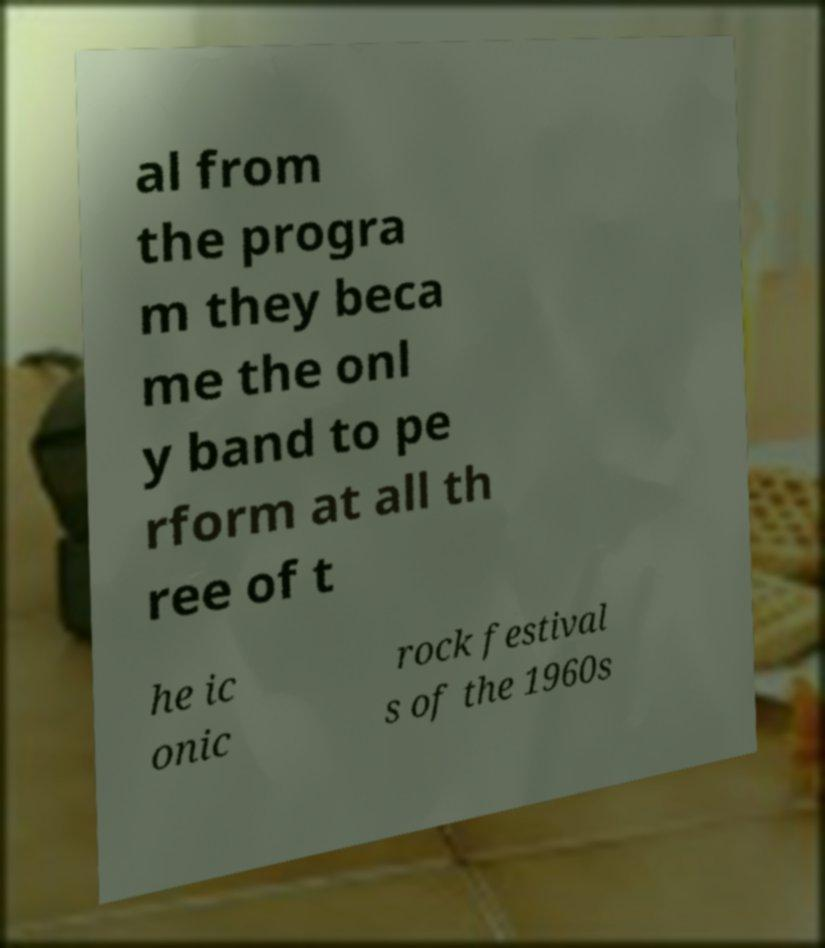For documentation purposes, I need the text within this image transcribed. Could you provide that? al from the progra m they beca me the onl y band to pe rform at all th ree of t he ic onic rock festival s of the 1960s 